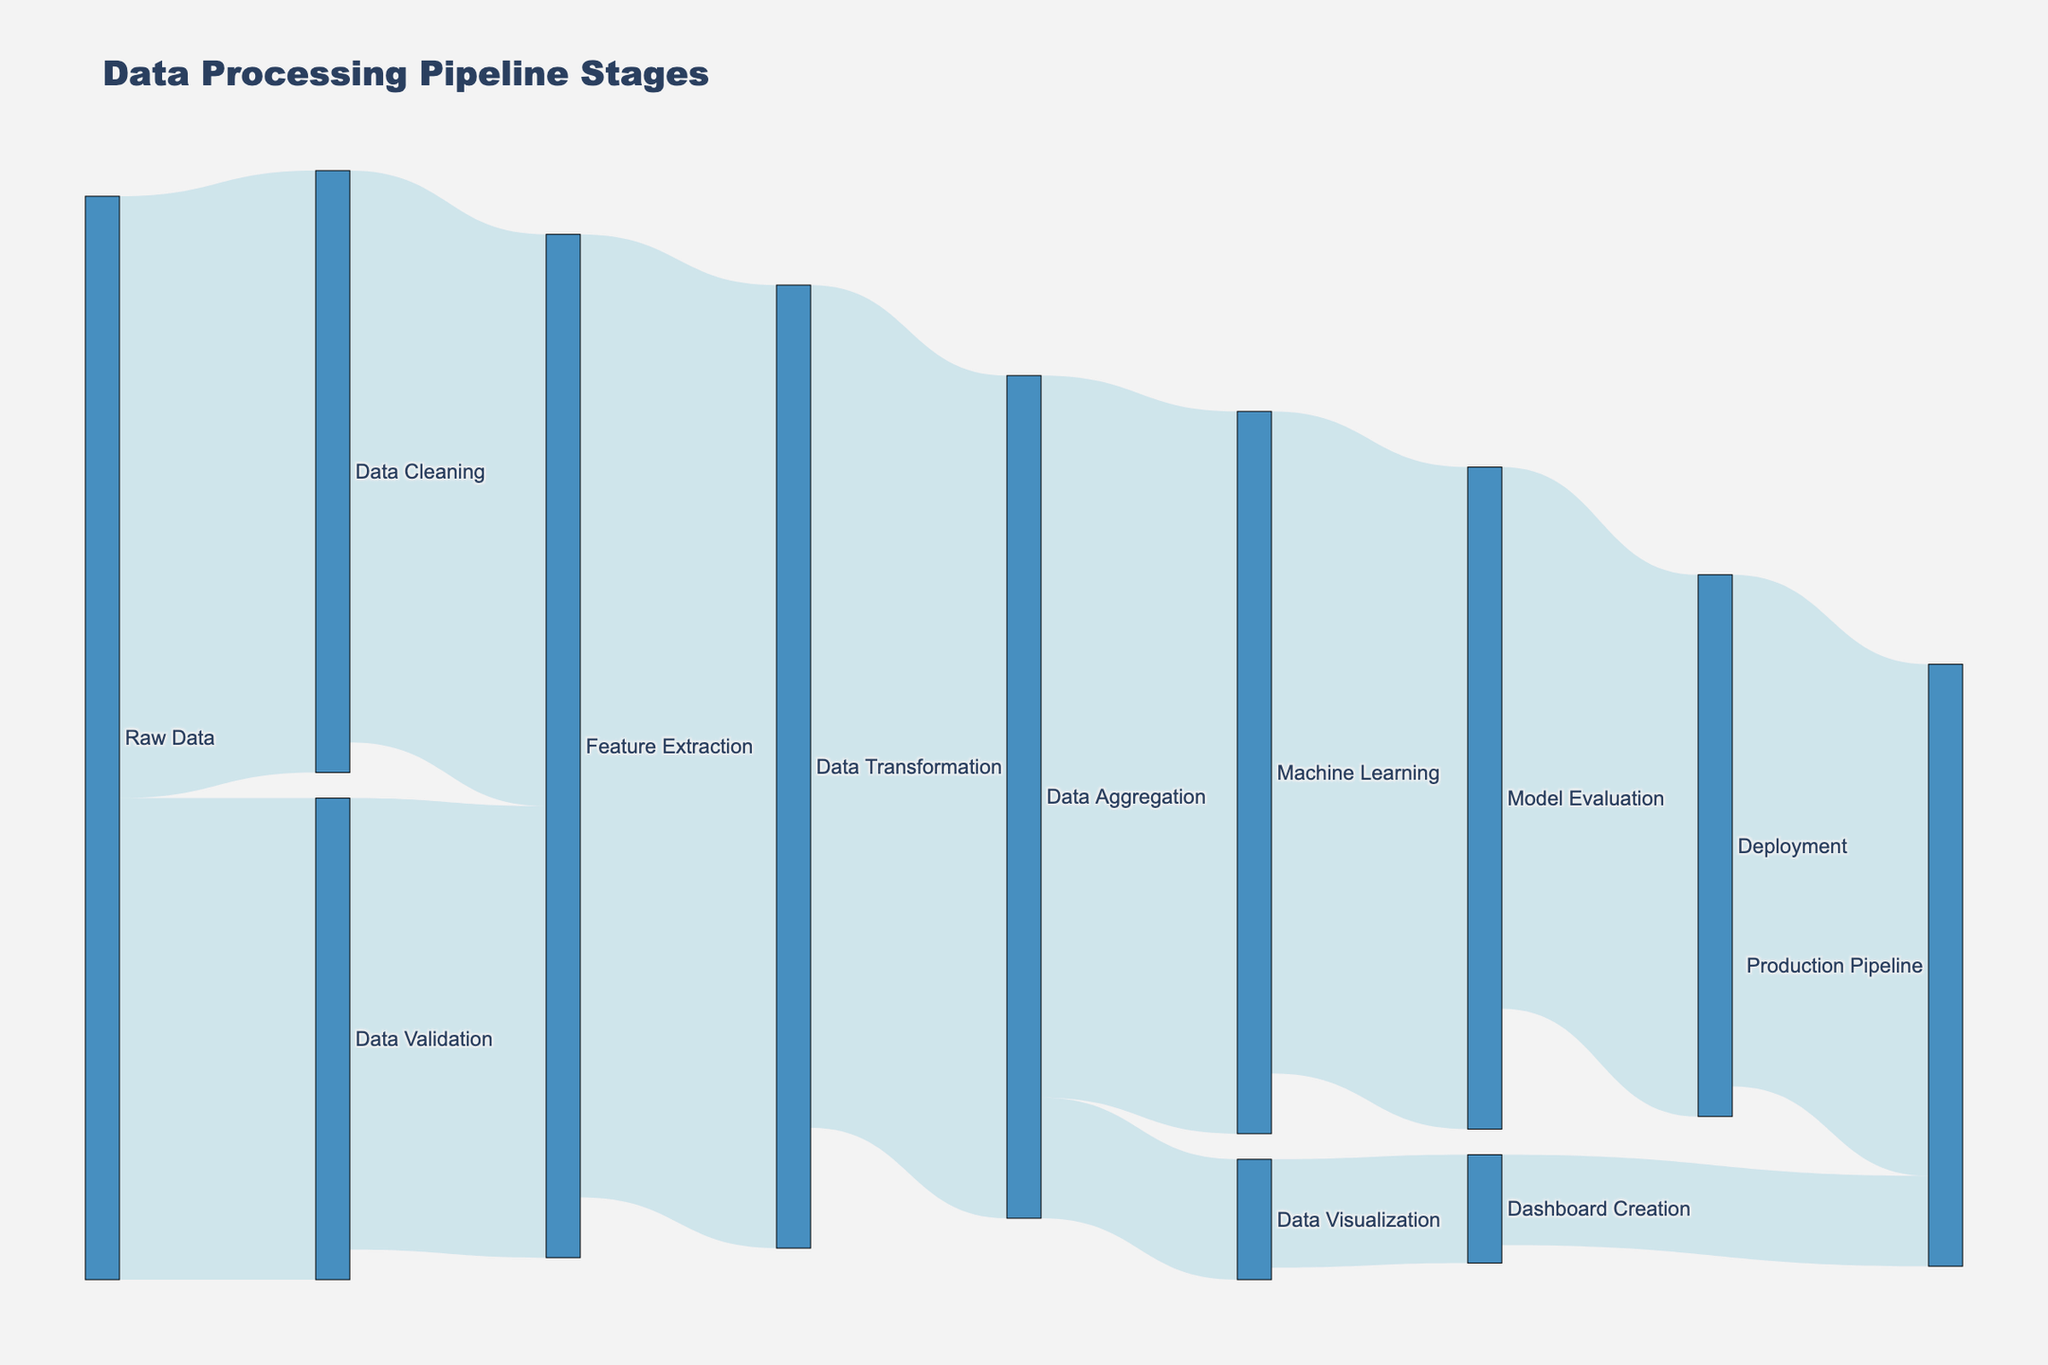What's the title of the figure? The title is displayed prominently at the top of the figure, and it reads "Data Processing Pipeline Stages".
Answer: Data Processing Pipeline Stages How many unique stages are represented in the figure? To find the number of unique stages, you count all the distinct labels in the source and target columns. Each label represents a unique stage.
Answer: 12 Which stage receives the highest volume of data from 'Raw Data'? Look at the connections from 'Raw Data' to other stages. Compare the values of these connections to determine the maximum. 'Data Cleaning' has a value of 1000, and 'Data Validation' has 800.
Answer: Data Cleaning What is the total volume of data processed by 'Feature Extraction'? Sum the incoming values to 'Feature Extraction', which are from 'Data Cleaning' (950) and 'Data Validation' (750). Then compare to the outgoing value. Incoming: 950 + 750 = 1700; Outgoing: 1700 (to 'Data Transformation'). No data is lost at this stage.
Answer: 1700 How much data does 'Machine Learning' output to 'Model Evaluation'? Trace the connection link from 'Machine Learning' to 'Model Evaluation' and read the value.
Answer: 1100 Between 'Data Aggregation' and 'Machine Learning', which stage deals with a higher volume of data? Compare the total outgoing values from 'Data Aggregation' (1200 to 'Machine Learning' and 200 to 'Data Visualization', total 1400) and the incoming value to 'Machine Learning' (1200).
Answer: Data Aggregation How much data is lost between 'Raw Data' and 'Deployment'? Calculate the total values from the initial stage 'Raw Data' (1000 + 800 = 1800) and trace the reductions through the pipeline until 'Deployment' (900). Total data loss: 1800 - 900 = 900.
Answer: 900 What is the proportion of data moving from 'Data Aggregation' to 'Data Visualization' compared to 'Machine Learning'? Divide the volume going to 'Data Visualization' (200) by the total outgoing from 'Data Aggregation' (1400). Proportion: 200 / 1400 = 1/7 (or approximately 0.14).
Answer: 1/7 How many stages directly send data to 'Production Pipeline'? Count the distinct direct connections leading to 'Production Pipeline'. They are from 'Deployment' (850) and 'Dashboard Creation' (150).
Answer: 2 Which stage has the smallest outgoing data volume and what is that volume? Look for the smallest value in the outgoing connections. 'Data Visualization' to 'Dashboard Creation' has the smallest value of 180.
Answer: Data Visualization, 180 